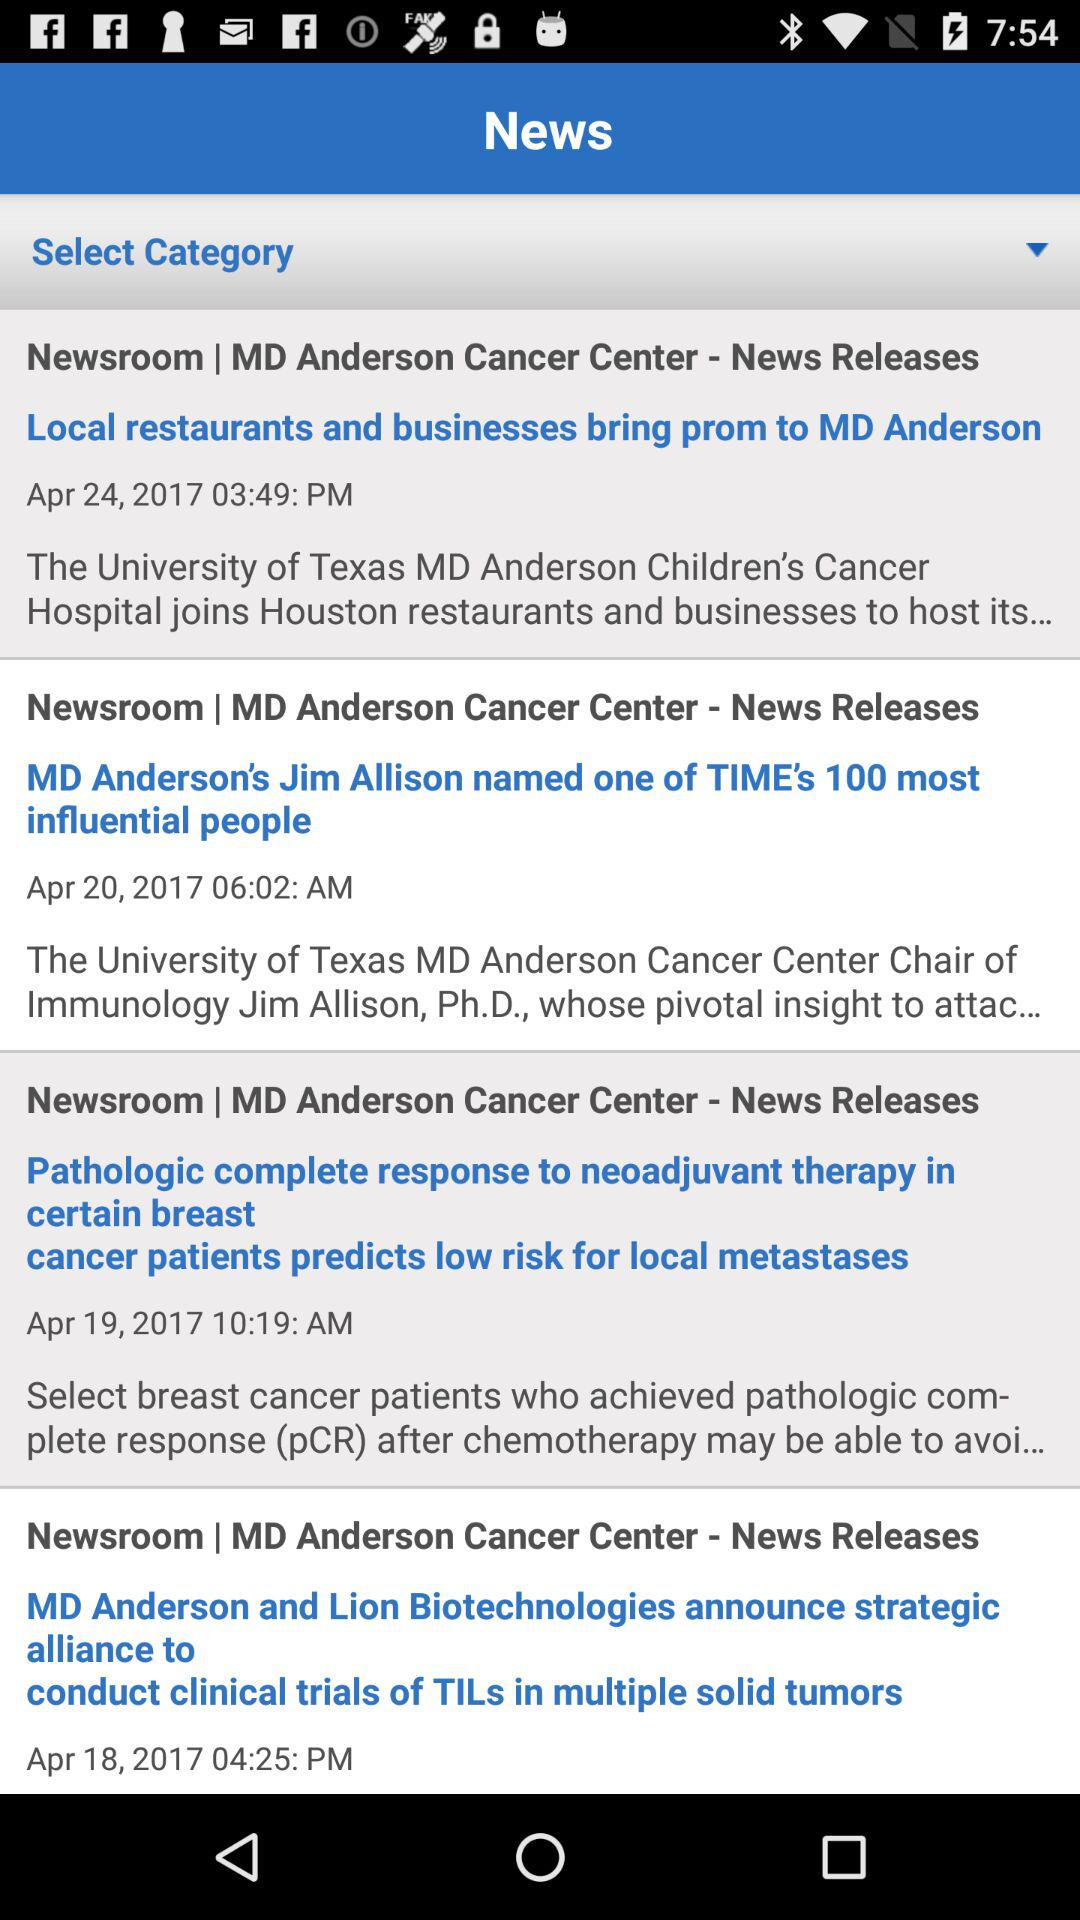What is the time of the news "Local restaurants and businesses bring prom to MD Anderson"? The time is 03:49 PM. 